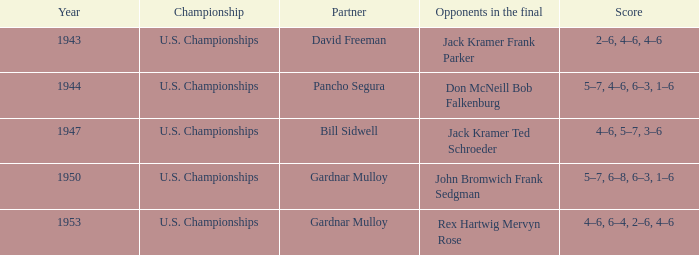Who are the opponents in the final with scores of 4-6, 6-4, 2-6, and 4-6? Rex Hartwig Mervyn Rose. 